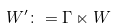<formula> <loc_0><loc_0><loc_500><loc_500>W ^ { \prime } \colon = \Gamma \ltimes W</formula> 